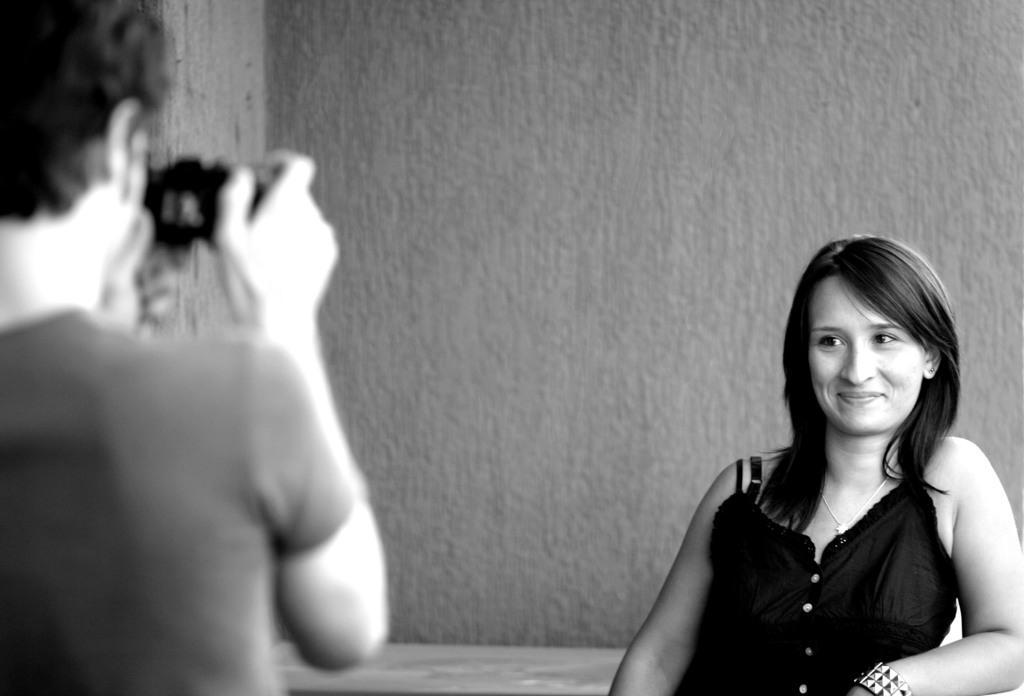Can you describe this image briefly? This is a black and white image. In this image we can see a man and a woman. In that a man is holding a camera. On the backside we can see a wall. 